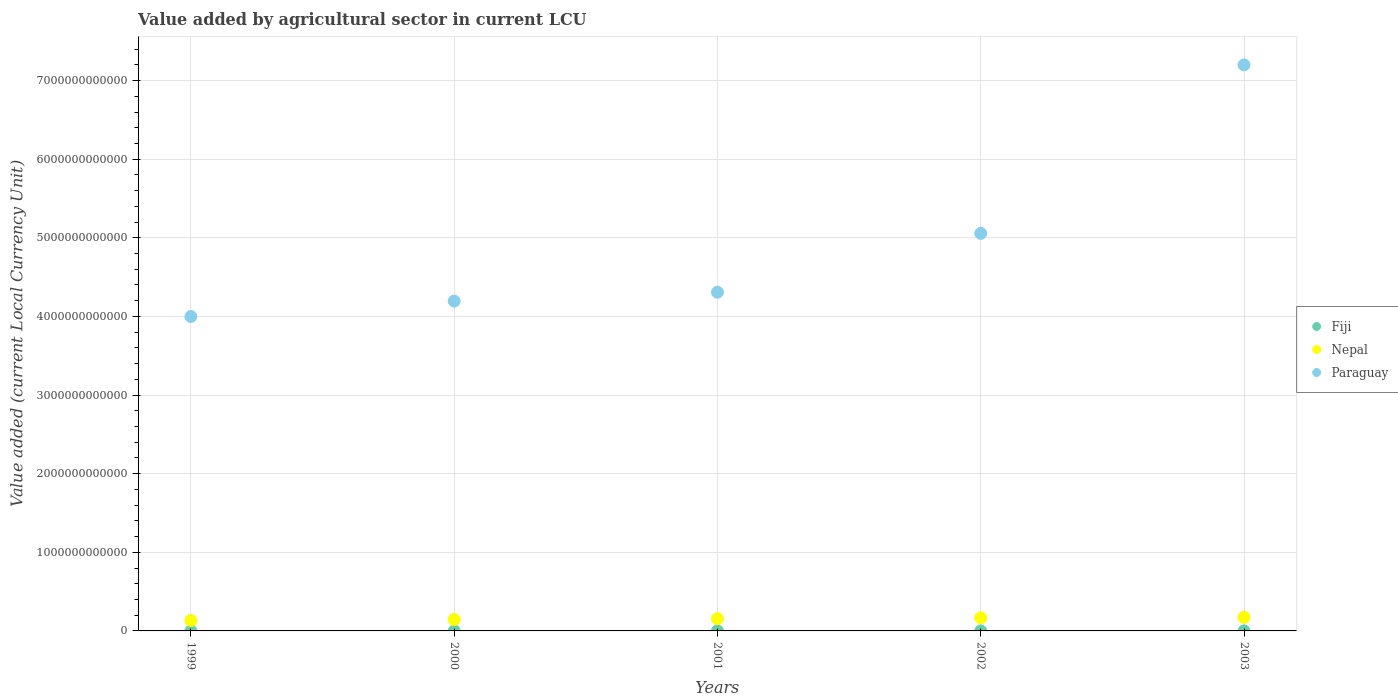How many different coloured dotlines are there?
Offer a very short reply. 3. Is the number of dotlines equal to the number of legend labels?
Offer a very short reply. Yes. What is the value added by agricultural sector in Nepal in 2001?
Your response must be concise. 1.56e+11. Across all years, what is the maximum value added by agricultural sector in Nepal?
Offer a very short reply. 1.73e+11. Across all years, what is the minimum value added by agricultural sector in Nepal?
Keep it short and to the point. 1.32e+11. In which year was the value added by agricultural sector in Paraguay maximum?
Offer a terse response. 2003. In which year was the value added by agricultural sector in Paraguay minimum?
Your answer should be compact. 1999. What is the total value added by agricultural sector in Paraguay in the graph?
Your answer should be very brief. 2.48e+13. What is the difference between the value added by agricultural sector in Nepal in 1999 and that in 2003?
Your answer should be compact. -4.04e+1. What is the difference between the value added by agricultural sector in Paraguay in 2003 and the value added by agricultural sector in Nepal in 2001?
Your response must be concise. 7.04e+12. What is the average value added by agricultural sector in Fiji per year?
Your answer should be very brief. 5.46e+08. In the year 2002, what is the difference between the value added by agricultural sector in Paraguay and value added by agricultural sector in Nepal?
Ensure brevity in your answer.  4.89e+12. What is the ratio of the value added by agricultural sector in Paraguay in 2001 to that in 2003?
Your answer should be very brief. 0.6. Is the value added by agricultural sector in Paraguay in 2000 less than that in 2001?
Ensure brevity in your answer.  Yes. Is the difference between the value added by agricultural sector in Paraguay in 2000 and 2003 greater than the difference between the value added by agricultural sector in Nepal in 2000 and 2003?
Give a very brief answer. No. What is the difference between the highest and the second highest value added by agricultural sector in Paraguay?
Offer a very short reply. 2.14e+12. What is the difference between the highest and the lowest value added by agricultural sector in Paraguay?
Provide a short and direct response. 3.20e+12. In how many years, is the value added by agricultural sector in Nepal greater than the average value added by agricultural sector in Nepal taken over all years?
Give a very brief answer. 3. Is the value added by agricultural sector in Nepal strictly greater than the value added by agricultural sector in Fiji over the years?
Make the answer very short. Yes. Is the value added by agricultural sector in Nepal strictly less than the value added by agricultural sector in Paraguay over the years?
Provide a succinct answer. Yes. What is the difference between two consecutive major ticks on the Y-axis?
Offer a very short reply. 1.00e+12. Does the graph contain any zero values?
Offer a terse response. No. What is the title of the graph?
Provide a short and direct response. Value added by agricultural sector in current LCU. Does "Sudan" appear as one of the legend labels in the graph?
Offer a very short reply. No. What is the label or title of the X-axis?
Provide a succinct answer. Years. What is the label or title of the Y-axis?
Provide a short and direct response. Value added (current Local Currency Unit). What is the Value added (current Local Currency Unit) in Fiji in 1999?
Make the answer very short. 6.26e+08. What is the Value added (current Local Currency Unit) in Nepal in 1999?
Give a very brief answer. 1.32e+11. What is the Value added (current Local Currency Unit) of Paraguay in 1999?
Your answer should be very brief. 4.00e+12. What is the Value added (current Local Currency Unit) in Fiji in 2000?
Offer a terse response. 5.35e+08. What is the Value added (current Local Currency Unit) in Nepal in 2000?
Provide a short and direct response. 1.45e+11. What is the Value added (current Local Currency Unit) in Paraguay in 2000?
Your response must be concise. 4.19e+12. What is the Value added (current Local Currency Unit) in Fiji in 2001?
Your answer should be very brief. 4.90e+08. What is the Value added (current Local Currency Unit) of Nepal in 2001?
Keep it short and to the point. 1.56e+11. What is the Value added (current Local Currency Unit) of Paraguay in 2001?
Offer a very short reply. 4.31e+12. What is the Value added (current Local Currency Unit) in Fiji in 2002?
Your answer should be very brief. 5.34e+08. What is the Value added (current Local Currency Unit) of Nepal in 2002?
Keep it short and to the point. 1.66e+11. What is the Value added (current Local Currency Unit) of Paraguay in 2002?
Give a very brief answer. 5.06e+12. What is the Value added (current Local Currency Unit) of Fiji in 2003?
Provide a succinct answer. 5.46e+08. What is the Value added (current Local Currency Unit) of Nepal in 2003?
Offer a very short reply. 1.73e+11. What is the Value added (current Local Currency Unit) in Paraguay in 2003?
Make the answer very short. 7.20e+12. Across all years, what is the maximum Value added (current Local Currency Unit) of Fiji?
Ensure brevity in your answer.  6.26e+08. Across all years, what is the maximum Value added (current Local Currency Unit) in Nepal?
Make the answer very short. 1.73e+11. Across all years, what is the maximum Value added (current Local Currency Unit) in Paraguay?
Make the answer very short. 7.20e+12. Across all years, what is the minimum Value added (current Local Currency Unit) of Fiji?
Ensure brevity in your answer.  4.90e+08. Across all years, what is the minimum Value added (current Local Currency Unit) in Nepal?
Ensure brevity in your answer.  1.32e+11. Across all years, what is the minimum Value added (current Local Currency Unit) in Paraguay?
Ensure brevity in your answer.  4.00e+12. What is the total Value added (current Local Currency Unit) of Fiji in the graph?
Give a very brief answer. 2.73e+09. What is the total Value added (current Local Currency Unit) in Nepal in the graph?
Your answer should be compact. 7.72e+11. What is the total Value added (current Local Currency Unit) in Paraguay in the graph?
Your response must be concise. 2.48e+13. What is the difference between the Value added (current Local Currency Unit) in Fiji in 1999 and that in 2000?
Your answer should be compact. 9.03e+07. What is the difference between the Value added (current Local Currency Unit) of Nepal in 1999 and that in 2000?
Your answer should be compact. -1.28e+1. What is the difference between the Value added (current Local Currency Unit) in Paraguay in 1999 and that in 2000?
Provide a succinct answer. -1.96e+11. What is the difference between the Value added (current Local Currency Unit) in Fiji in 1999 and that in 2001?
Ensure brevity in your answer.  1.36e+08. What is the difference between the Value added (current Local Currency Unit) of Nepal in 1999 and that in 2001?
Your answer should be very brief. -2.33e+1. What is the difference between the Value added (current Local Currency Unit) of Paraguay in 1999 and that in 2001?
Your answer should be compact. -3.09e+11. What is the difference between the Value added (current Local Currency Unit) in Fiji in 1999 and that in 2002?
Your answer should be compact. 9.20e+07. What is the difference between the Value added (current Local Currency Unit) in Nepal in 1999 and that in 2002?
Provide a succinct answer. -3.37e+1. What is the difference between the Value added (current Local Currency Unit) in Paraguay in 1999 and that in 2002?
Your answer should be compact. -1.06e+12. What is the difference between the Value added (current Local Currency Unit) in Fiji in 1999 and that in 2003?
Ensure brevity in your answer.  7.99e+07. What is the difference between the Value added (current Local Currency Unit) of Nepal in 1999 and that in 2003?
Ensure brevity in your answer.  -4.04e+1. What is the difference between the Value added (current Local Currency Unit) in Paraguay in 1999 and that in 2003?
Give a very brief answer. -3.20e+12. What is the difference between the Value added (current Local Currency Unit) in Fiji in 2000 and that in 2001?
Your answer should be very brief. 4.59e+07. What is the difference between the Value added (current Local Currency Unit) in Nepal in 2000 and that in 2001?
Ensure brevity in your answer.  -1.05e+1. What is the difference between the Value added (current Local Currency Unit) of Paraguay in 2000 and that in 2001?
Offer a very short reply. -1.13e+11. What is the difference between the Value added (current Local Currency Unit) of Fiji in 2000 and that in 2002?
Your response must be concise. 1.74e+06. What is the difference between the Value added (current Local Currency Unit) of Nepal in 2000 and that in 2002?
Make the answer very short. -2.10e+1. What is the difference between the Value added (current Local Currency Unit) of Paraguay in 2000 and that in 2002?
Offer a terse response. -8.62e+11. What is the difference between the Value added (current Local Currency Unit) in Fiji in 2000 and that in 2003?
Ensure brevity in your answer.  -1.04e+07. What is the difference between the Value added (current Local Currency Unit) in Nepal in 2000 and that in 2003?
Your answer should be very brief. -2.77e+1. What is the difference between the Value added (current Local Currency Unit) in Paraguay in 2000 and that in 2003?
Make the answer very short. -3.01e+12. What is the difference between the Value added (current Local Currency Unit) in Fiji in 2001 and that in 2002?
Provide a short and direct response. -4.41e+07. What is the difference between the Value added (current Local Currency Unit) in Nepal in 2001 and that in 2002?
Ensure brevity in your answer.  -1.05e+1. What is the difference between the Value added (current Local Currency Unit) in Paraguay in 2001 and that in 2002?
Your answer should be compact. -7.48e+11. What is the difference between the Value added (current Local Currency Unit) in Fiji in 2001 and that in 2003?
Your response must be concise. -5.62e+07. What is the difference between the Value added (current Local Currency Unit) in Nepal in 2001 and that in 2003?
Your answer should be compact. -1.72e+1. What is the difference between the Value added (current Local Currency Unit) of Paraguay in 2001 and that in 2003?
Your answer should be very brief. -2.89e+12. What is the difference between the Value added (current Local Currency Unit) in Fiji in 2002 and that in 2003?
Provide a short and direct response. -1.21e+07. What is the difference between the Value added (current Local Currency Unit) of Nepal in 2002 and that in 2003?
Your answer should be compact. -6.71e+09. What is the difference between the Value added (current Local Currency Unit) of Paraguay in 2002 and that in 2003?
Your answer should be compact. -2.14e+12. What is the difference between the Value added (current Local Currency Unit) of Fiji in 1999 and the Value added (current Local Currency Unit) of Nepal in 2000?
Keep it short and to the point. -1.45e+11. What is the difference between the Value added (current Local Currency Unit) in Fiji in 1999 and the Value added (current Local Currency Unit) in Paraguay in 2000?
Offer a terse response. -4.19e+12. What is the difference between the Value added (current Local Currency Unit) of Nepal in 1999 and the Value added (current Local Currency Unit) of Paraguay in 2000?
Keep it short and to the point. -4.06e+12. What is the difference between the Value added (current Local Currency Unit) in Fiji in 1999 and the Value added (current Local Currency Unit) in Nepal in 2001?
Make the answer very short. -1.55e+11. What is the difference between the Value added (current Local Currency Unit) in Fiji in 1999 and the Value added (current Local Currency Unit) in Paraguay in 2001?
Provide a succinct answer. -4.31e+12. What is the difference between the Value added (current Local Currency Unit) in Nepal in 1999 and the Value added (current Local Currency Unit) in Paraguay in 2001?
Your response must be concise. -4.18e+12. What is the difference between the Value added (current Local Currency Unit) in Fiji in 1999 and the Value added (current Local Currency Unit) in Nepal in 2002?
Your answer should be very brief. -1.65e+11. What is the difference between the Value added (current Local Currency Unit) of Fiji in 1999 and the Value added (current Local Currency Unit) of Paraguay in 2002?
Offer a very short reply. -5.06e+12. What is the difference between the Value added (current Local Currency Unit) in Nepal in 1999 and the Value added (current Local Currency Unit) in Paraguay in 2002?
Offer a very short reply. -4.92e+12. What is the difference between the Value added (current Local Currency Unit) of Fiji in 1999 and the Value added (current Local Currency Unit) of Nepal in 2003?
Your answer should be very brief. -1.72e+11. What is the difference between the Value added (current Local Currency Unit) of Fiji in 1999 and the Value added (current Local Currency Unit) of Paraguay in 2003?
Provide a succinct answer. -7.20e+12. What is the difference between the Value added (current Local Currency Unit) of Nepal in 1999 and the Value added (current Local Currency Unit) of Paraguay in 2003?
Keep it short and to the point. -7.07e+12. What is the difference between the Value added (current Local Currency Unit) in Fiji in 2000 and the Value added (current Local Currency Unit) in Nepal in 2001?
Give a very brief answer. -1.55e+11. What is the difference between the Value added (current Local Currency Unit) of Fiji in 2000 and the Value added (current Local Currency Unit) of Paraguay in 2001?
Provide a succinct answer. -4.31e+12. What is the difference between the Value added (current Local Currency Unit) in Nepal in 2000 and the Value added (current Local Currency Unit) in Paraguay in 2001?
Keep it short and to the point. -4.16e+12. What is the difference between the Value added (current Local Currency Unit) in Fiji in 2000 and the Value added (current Local Currency Unit) in Nepal in 2002?
Provide a succinct answer. -1.66e+11. What is the difference between the Value added (current Local Currency Unit) of Fiji in 2000 and the Value added (current Local Currency Unit) of Paraguay in 2002?
Give a very brief answer. -5.06e+12. What is the difference between the Value added (current Local Currency Unit) of Nepal in 2000 and the Value added (current Local Currency Unit) of Paraguay in 2002?
Offer a very short reply. -4.91e+12. What is the difference between the Value added (current Local Currency Unit) in Fiji in 2000 and the Value added (current Local Currency Unit) in Nepal in 2003?
Ensure brevity in your answer.  -1.72e+11. What is the difference between the Value added (current Local Currency Unit) in Fiji in 2000 and the Value added (current Local Currency Unit) in Paraguay in 2003?
Give a very brief answer. -7.20e+12. What is the difference between the Value added (current Local Currency Unit) of Nepal in 2000 and the Value added (current Local Currency Unit) of Paraguay in 2003?
Your response must be concise. -7.05e+12. What is the difference between the Value added (current Local Currency Unit) in Fiji in 2001 and the Value added (current Local Currency Unit) in Nepal in 2002?
Provide a short and direct response. -1.66e+11. What is the difference between the Value added (current Local Currency Unit) of Fiji in 2001 and the Value added (current Local Currency Unit) of Paraguay in 2002?
Offer a very short reply. -5.06e+12. What is the difference between the Value added (current Local Currency Unit) in Nepal in 2001 and the Value added (current Local Currency Unit) in Paraguay in 2002?
Your answer should be very brief. -4.90e+12. What is the difference between the Value added (current Local Currency Unit) in Fiji in 2001 and the Value added (current Local Currency Unit) in Nepal in 2003?
Keep it short and to the point. -1.72e+11. What is the difference between the Value added (current Local Currency Unit) in Fiji in 2001 and the Value added (current Local Currency Unit) in Paraguay in 2003?
Ensure brevity in your answer.  -7.20e+12. What is the difference between the Value added (current Local Currency Unit) in Nepal in 2001 and the Value added (current Local Currency Unit) in Paraguay in 2003?
Your response must be concise. -7.04e+12. What is the difference between the Value added (current Local Currency Unit) in Fiji in 2002 and the Value added (current Local Currency Unit) in Nepal in 2003?
Make the answer very short. -1.72e+11. What is the difference between the Value added (current Local Currency Unit) of Fiji in 2002 and the Value added (current Local Currency Unit) of Paraguay in 2003?
Your answer should be compact. -7.20e+12. What is the difference between the Value added (current Local Currency Unit) in Nepal in 2002 and the Value added (current Local Currency Unit) in Paraguay in 2003?
Give a very brief answer. -7.03e+12. What is the average Value added (current Local Currency Unit) in Fiji per year?
Make the answer very short. 5.46e+08. What is the average Value added (current Local Currency Unit) of Nepal per year?
Provide a short and direct response. 1.54e+11. What is the average Value added (current Local Currency Unit) in Paraguay per year?
Offer a terse response. 4.95e+12. In the year 1999, what is the difference between the Value added (current Local Currency Unit) of Fiji and Value added (current Local Currency Unit) of Nepal?
Keep it short and to the point. -1.32e+11. In the year 1999, what is the difference between the Value added (current Local Currency Unit) of Fiji and Value added (current Local Currency Unit) of Paraguay?
Keep it short and to the point. -4.00e+12. In the year 1999, what is the difference between the Value added (current Local Currency Unit) in Nepal and Value added (current Local Currency Unit) in Paraguay?
Provide a short and direct response. -3.87e+12. In the year 2000, what is the difference between the Value added (current Local Currency Unit) in Fiji and Value added (current Local Currency Unit) in Nepal?
Your response must be concise. -1.45e+11. In the year 2000, what is the difference between the Value added (current Local Currency Unit) in Fiji and Value added (current Local Currency Unit) in Paraguay?
Provide a succinct answer. -4.19e+12. In the year 2000, what is the difference between the Value added (current Local Currency Unit) of Nepal and Value added (current Local Currency Unit) of Paraguay?
Offer a terse response. -4.05e+12. In the year 2001, what is the difference between the Value added (current Local Currency Unit) of Fiji and Value added (current Local Currency Unit) of Nepal?
Ensure brevity in your answer.  -1.55e+11. In the year 2001, what is the difference between the Value added (current Local Currency Unit) in Fiji and Value added (current Local Currency Unit) in Paraguay?
Give a very brief answer. -4.31e+12. In the year 2001, what is the difference between the Value added (current Local Currency Unit) in Nepal and Value added (current Local Currency Unit) in Paraguay?
Ensure brevity in your answer.  -4.15e+12. In the year 2002, what is the difference between the Value added (current Local Currency Unit) in Fiji and Value added (current Local Currency Unit) in Nepal?
Offer a very short reply. -1.66e+11. In the year 2002, what is the difference between the Value added (current Local Currency Unit) of Fiji and Value added (current Local Currency Unit) of Paraguay?
Keep it short and to the point. -5.06e+12. In the year 2002, what is the difference between the Value added (current Local Currency Unit) of Nepal and Value added (current Local Currency Unit) of Paraguay?
Provide a short and direct response. -4.89e+12. In the year 2003, what is the difference between the Value added (current Local Currency Unit) in Fiji and Value added (current Local Currency Unit) in Nepal?
Make the answer very short. -1.72e+11. In the year 2003, what is the difference between the Value added (current Local Currency Unit) of Fiji and Value added (current Local Currency Unit) of Paraguay?
Your answer should be very brief. -7.20e+12. In the year 2003, what is the difference between the Value added (current Local Currency Unit) in Nepal and Value added (current Local Currency Unit) in Paraguay?
Ensure brevity in your answer.  -7.03e+12. What is the ratio of the Value added (current Local Currency Unit) in Fiji in 1999 to that in 2000?
Ensure brevity in your answer.  1.17. What is the ratio of the Value added (current Local Currency Unit) of Nepal in 1999 to that in 2000?
Your answer should be very brief. 0.91. What is the ratio of the Value added (current Local Currency Unit) of Paraguay in 1999 to that in 2000?
Make the answer very short. 0.95. What is the ratio of the Value added (current Local Currency Unit) of Fiji in 1999 to that in 2001?
Provide a succinct answer. 1.28. What is the ratio of the Value added (current Local Currency Unit) of Nepal in 1999 to that in 2001?
Give a very brief answer. 0.85. What is the ratio of the Value added (current Local Currency Unit) of Paraguay in 1999 to that in 2001?
Keep it short and to the point. 0.93. What is the ratio of the Value added (current Local Currency Unit) in Fiji in 1999 to that in 2002?
Offer a terse response. 1.17. What is the ratio of the Value added (current Local Currency Unit) in Nepal in 1999 to that in 2002?
Offer a very short reply. 0.8. What is the ratio of the Value added (current Local Currency Unit) in Paraguay in 1999 to that in 2002?
Provide a succinct answer. 0.79. What is the ratio of the Value added (current Local Currency Unit) in Fiji in 1999 to that in 2003?
Make the answer very short. 1.15. What is the ratio of the Value added (current Local Currency Unit) of Nepal in 1999 to that in 2003?
Your answer should be very brief. 0.77. What is the ratio of the Value added (current Local Currency Unit) of Paraguay in 1999 to that in 2003?
Give a very brief answer. 0.56. What is the ratio of the Value added (current Local Currency Unit) of Fiji in 2000 to that in 2001?
Your response must be concise. 1.09. What is the ratio of the Value added (current Local Currency Unit) in Nepal in 2000 to that in 2001?
Your answer should be compact. 0.93. What is the ratio of the Value added (current Local Currency Unit) in Paraguay in 2000 to that in 2001?
Offer a terse response. 0.97. What is the ratio of the Value added (current Local Currency Unit) in Nepal in 2000 to that in 2002?
Offer a very short reply. 0.87. What is the ratio of the Value added (current Local Currency Unit) of Paraguay in 2000 to that in 2002?
Offer a very short reply. 0.83. What is the ratio of the Value added (current Local Currency Unit) in Fiji in 2000 to that in 2003?
Your response must be concise. 0.98. What is the ratio of the Value added (current Local Currency Unit) of Nepal in 2000 to that in 2003?
Provide a short and direct response. 0.84. What is the ratio of the Value added (current Local Currency Unit) in Paraguay in 2000 to that in 2003?
Your answer should be very brief. 0.58. What is the ratio of the Value added (current Local Currency Unit) in Fiji in 2001 to that in 2002?
Offer a very short reply. 0.92. What is the ratio of the Value added (current Local Currency Unit) in Nepal in 2001 to that in 2002?
Your response must be concise. 0.94. What is the ratio of the Value added (current Local Currency Unit) in Paraguay in 2001 to that in 2002?
Ensure brevity in your answer.  0.85. What is the ratio of the Value added (current Local Currency Unit) in Fiji in 2001 to that in 2003?
Ensure brevity in your answer.  0.9. What is the ratio of the Value added (current Local Currency Unit) of Nepal in 2001 to that in 2003?
Provide a succinct answer. 0.9. What is the ratio of the Value added (current Local Currency Unit) in Paraguay in 2001 to that in 2003?
Keep it short and to the point. 0.6. What is the ratio of the Value added (current Local Currency Unit) in Fiji in 2002 to that in 2003?
Your answer should be very brief. 0.98. What is the ratio of the Value added (current Local Currency Unit) in Nepal in 2002 to that in 2003?
Offer a terse response. 0.96. What is the ratio of the Value added (current Local Currency Unit) in Paraguay in 2002 to that in 2003?
Provide a short and direct response. 0.7. What is the difference between the highest and the second highest Value added (current Local Currency Unit) in Fiji?
Offer a very short reply. 7.99e+07. What is the difference between the highest and the second highest Value added (current Local Currency Unit) of Nepal?
Make the answer very short. 6.71e+09. What is the difference between the highest and the second highest Value added (current Local Currency Unit) of Paraguay?
Make the answer very short. 2.14e+12. What is the difference between the highest and the lowest Value added (current Local Currency Unit) of Fiji?
Your response must be concise. 1.36e+08. What is the difference between the highest and the lowest Value added (current Local Currency Unit) in Nepal?
Offer a terse response. 4.04e+1. What is the difference between the highest and the lowest Value added (current Local Currency Unit) in Paraguay?
Offer a terse response. 3.20e+12. 